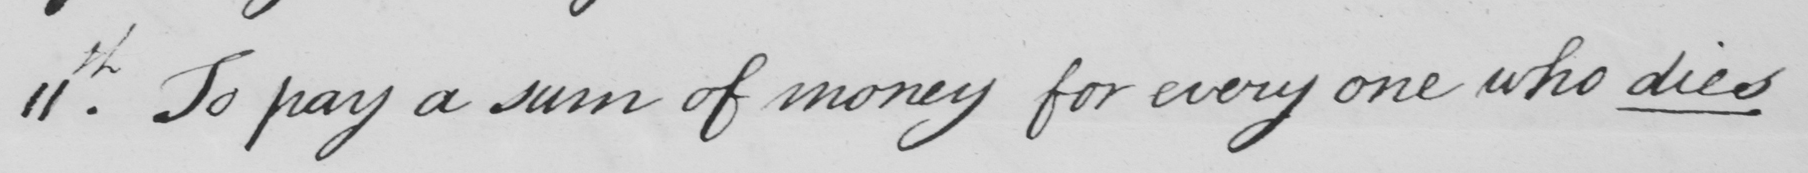Can you read and transcribe this handwriting? 11th . To pay a sum of money for every one who dies 